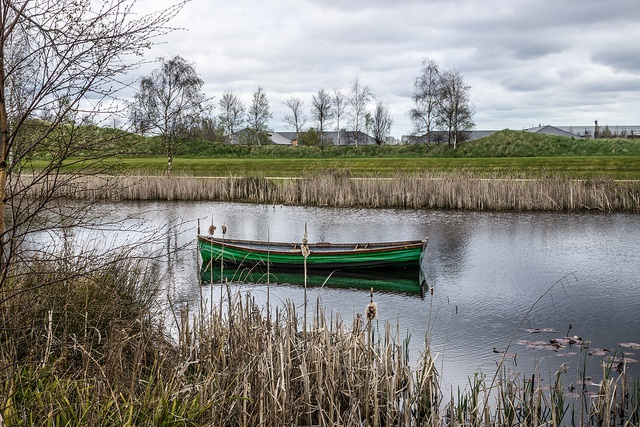Describe the objects in this image and their specific colors. I can see a boat in black, darkgreen, gray, and darkgray tones in this image. 